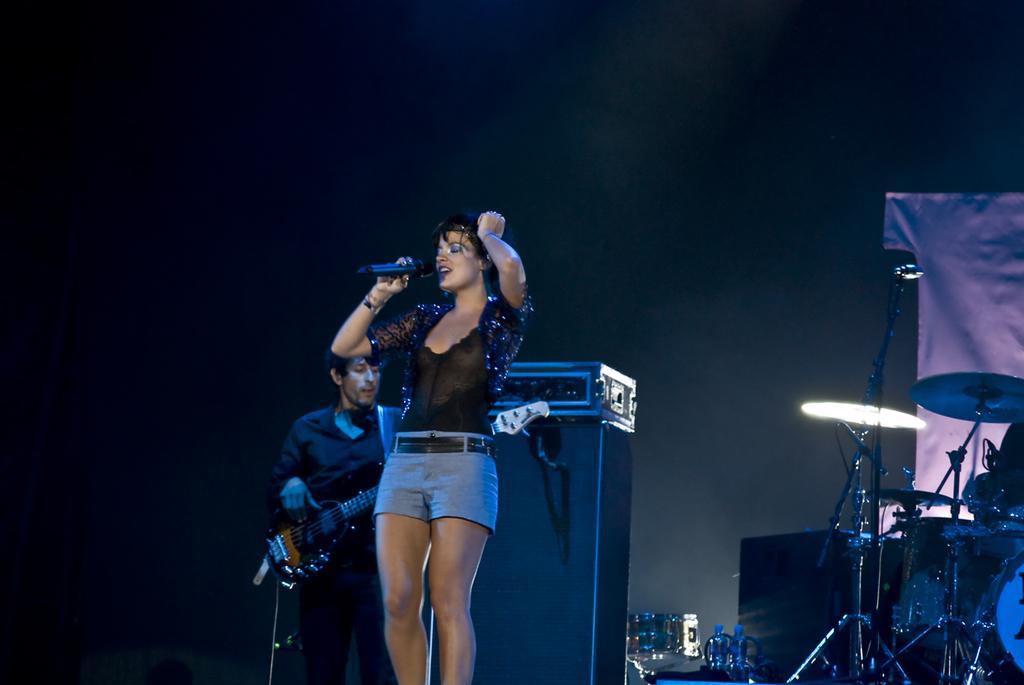Please provide a concise description of this image. As we can see in the image there are two people. the man who is standing here is holding guitar and this woman is holding mic and singing a song. On the right side there are musical drums. 